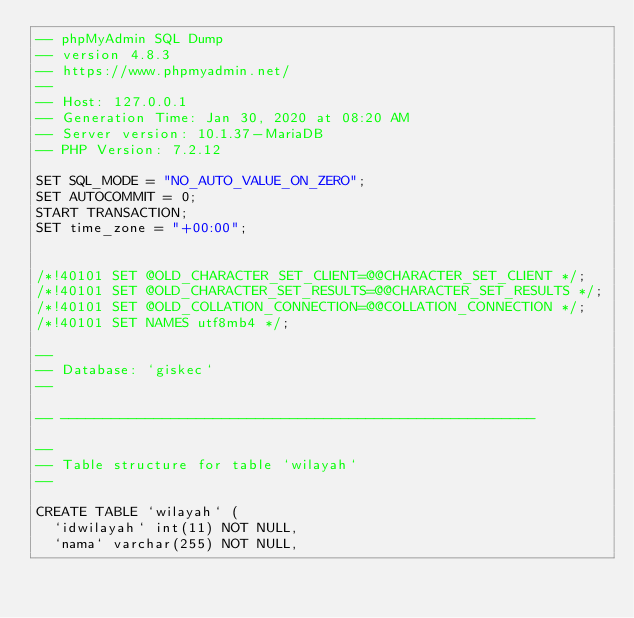Convert code to text. <code><loc_0><loc_0><loc_500><loc_500><_SQL_>-- phpMyAdmin SQL Dump
-- version 4.8.3
-- https://www.phpmyadmin.net/
--
-- Host: 127.0.0.1
-- Generation Time: Jan 30, 2020 at 08:20 AM
-- Server version: 10.1.37-MariaDB
-- PHP Version: 7.2.12

SET SQL_MODE = "NO_AUTO_VALUE_ON_ZERO";
SET AUTOCOMMIT = 0;
START TRANSACTION;
SET time_zone = "+00:00";


/*!40101 SET @OLD_CHARACTER_SET_CLIENT=@@CHARACTER_SET_CLIENT */;
/*!40101 SET @OLD_CHARACTER_SET_RESULTS=@@CHARACTER_SET_RESULTS */;
/*!40101 SET @OLD_COLLATION_CONNECTION=@@COLLATION_CONNECTION */;
/*!40101 SET NAMES utf8mb4 */;

--
-- Database: `giskec`
--

-- --------------------------------------------------------

--
-- Table structure for table `wilayah`
--

CREATE TABLE `wilayah` (
  `idwilayah` int(11) NOT NULL,
  `nama` varchar(255) NOT NULL,</code> 